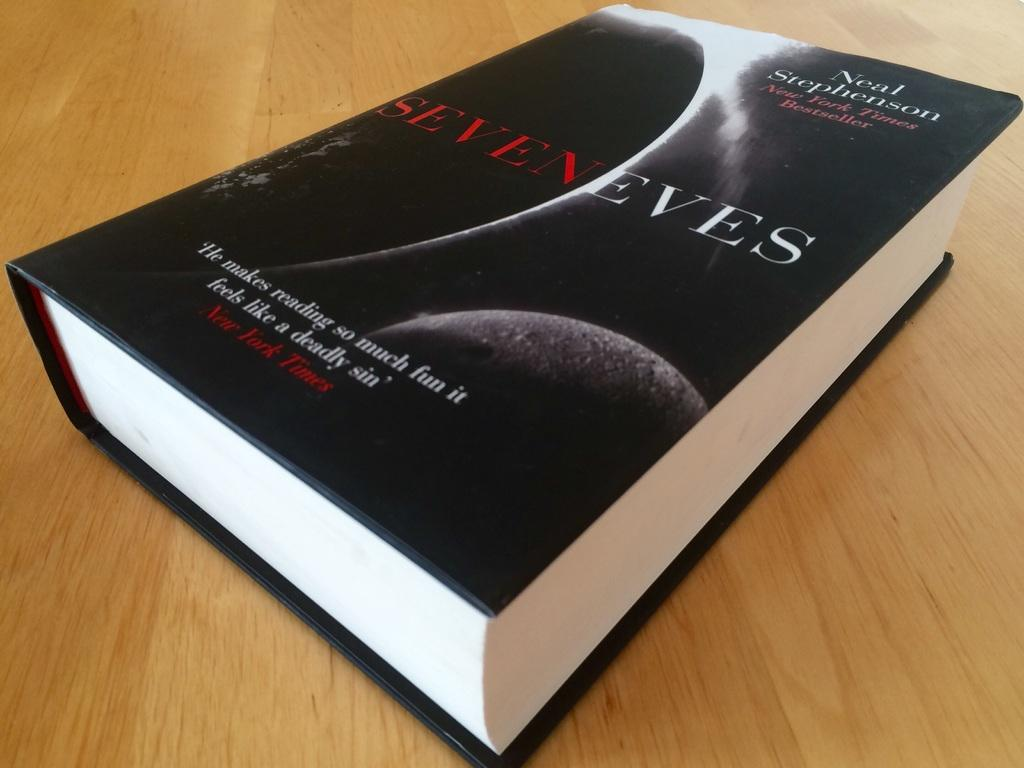Provide a one-sentence caption for the provided image. The new novel by Neal Stephenson "Seven Eves" is a great read. 